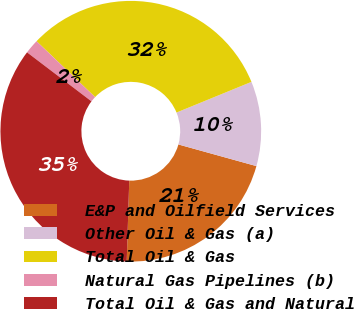Convert chart. <chart><loc_0><loc_0><loc_500><loc_500><pie_chart><fcel>E&P and Oilfield Services<fcel>Other Oil & Gas (a)<fcel>Total Oil & Gas<fcel>Natural Gas Pipelines (b)<fcel>Total Oil & Gas and Natural<nl><fcel>21.19%<fcel>10.49%<fcel>31.68%<fcel>1.79%<fcel>34.85%<nl></chart> 